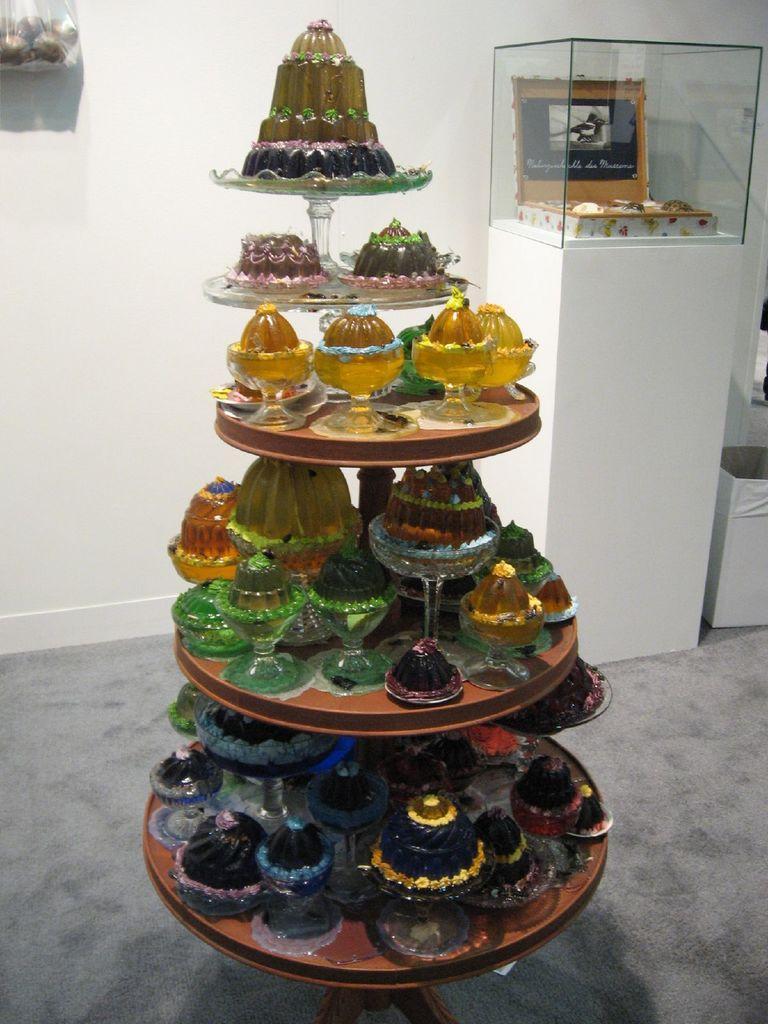Please provide a concise description of this image. There are different types of jellies kept on a plate, there are total five plates kept one below the another and in the background there is a white color wall and in front of the wall there is some object kept inside the glass box. 